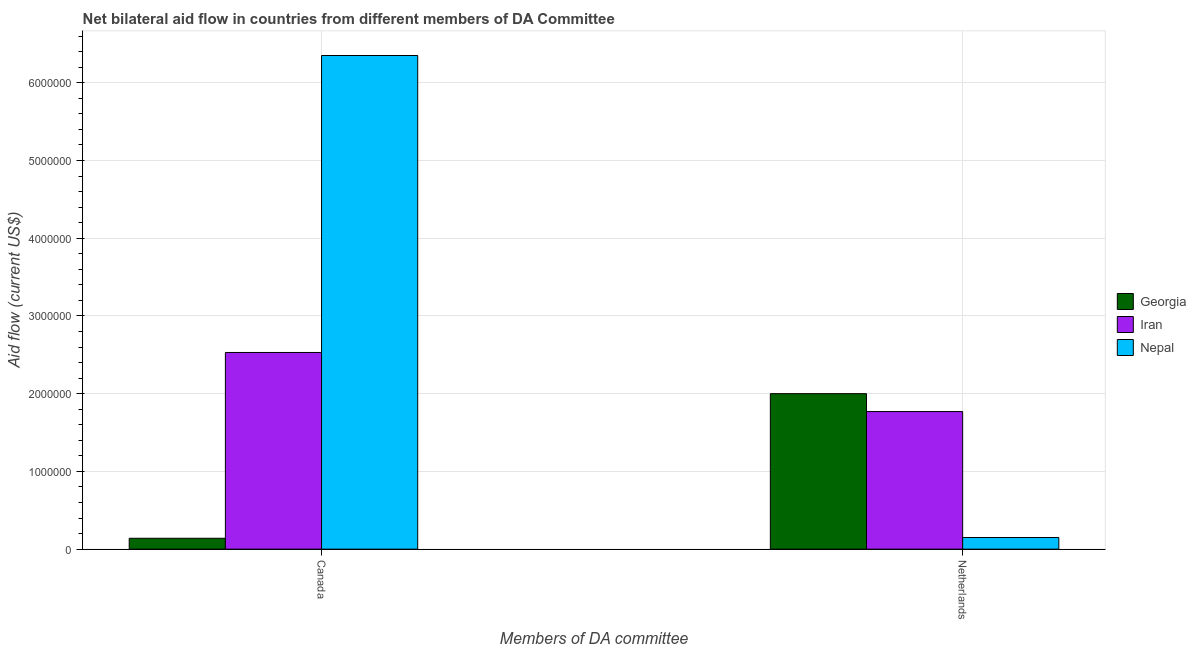How many groups of bars are there?
Your response must be concise. 2. Are the number of bars per tick equal to the number of legend labels?
Offer a very short reply. Yes. Are the number of bars on each tick of the X-axis equal?
Offer a terse response. Yes. How many bars are there on the 2nd tick from the left?
Offer a terse response. 3. What is the label of the 1st group of bars from the left?
Ensure brevity in your answer.  Canada. What is the amount of aid given by netherlands in Iran?
Provide a succinct answer. 1.77e+06. Across all countries, what is the maximum amount of aid given by netherlands?
Provide a succinct answer. 2.00e+06. Across all countries, what is the minimum amount of aid given by canada?
Keep it short and to the point. 1.40e+05. In which country was the amount of aid given by canada maximum?
Provide a short and direct response. Nepal. In which country was the amount of aid given by canada minimum?
Make the answer very short. Georgia. What is the total amount of aid given by netherlands in the graph?
Keep it short and to the point. 3.92e+06. What is the difference between the amount of aid given by canada in Nepal and that in Georgia?
Your answer should be very brief. 6.21e+06. What is the difference between the amount of aid given by netherlands in Iran and the amount of aid given by canada in Nepal?
Your answer should be very brief. -4.58e+06. What is the average amount of aid given by netherlands per country?
Provide a short and direct response. 1.31e+06. What is the difference between the amount of aid given by netherlands and amount of aid given by canada in Iran?
Give a very brief answer. -7.60e+05. In how many countries, is the amount of aid given by canada greater than 6400000 US$?
Your answer should be very brief. 0. What is the ratio of the amount of aid given by canada in Georgia to that in Iran?
Give a very brief answer. 0.06. What does the 3rd bar from the left in Canada represents?
Ensure brevity in your answer.  Nepal. What does the 3rd bar from the right in Netherlands represents?
Your answer should be very brief. Georgia. How many bars are there?
Provide a short and direct response. 6. Are all the bars in the graph horizontal?
Your answer should be compact. No. Are the values on the major ticks of Y-axis written in scientific E-notation?
Your answer should be very brief. No. How many legend labels are there?
Provide a succinct answer. 3. What is the title of the graph?
Keep it short and to the point. Net bilateral aid flow in countries from different members of DA Committee. Does "Thailand" appear as one of the legend labels in the graph?
Offer a very short reply. No. What is the label or title of the X-axis?
Provide a succinct answer. Members of DA committee. What is the label or title of the Y-axis?
Offer a terse response. Aid flow (current US$). What is the Aid flow (current US$) in Georgia in Canada?
Provide a short and direct response. 1.40e+05. What is the Aid flow (current US$) of Iran in Canada?
Your response must be concise. 2.53e+06. What is the Aid flow (current US$) of Nepal in Canada?
Your response must be concise. 6.35e+06. What is the Aid flow (current US$) of Iran in Netherlands?
Offer a terse response. 1.77e+06. What is the Aid flow (current US$) in Nepal in Netherlands?
Make the answer very short. 1.50e+05. Across all Members of DA committee, what is the maximum Aid flow (current US$) in Iran?
Ensure brevity in your answer.  2.53e+06. Across all Members of DA committee, what is the maximum Aid flow (current US$) in Nepal?
Give a very brief answer. 6.35e+06. Across all Members of DA committee, what is the minimum Aid flow (current US$) in Iran?
Provide a succinct answer. 1.77e+06. Across all Members of DA committee, what is the minimum Aid flow (current US$) in Nepal?
Your answer should be very brief. 1.50e+05. What is the total Aid flow (current US$) in Georgia in the graph?
Your response must be concise. 2.14e+06. What is the total Aid flow (current US$) in Iran in the graph?
Your answer should be compact. 4.30e+06. What is the total Aid flow (current US$) in Nepal in the graph?
Provide a succinct answer. 6.50e+06. What is the difference between the Aid flow (current US$) in Georgia in Canada and that in Netherlands?
Ensure brevity in your answer.  -1.86e+06. What is the difference between the Aid flow (current US$) of Iran in Canada and that in Netherlands?
Ensure brevity in your answer.  7.60e+05. What is the difference between the Aid flow (current US$) of Nepal in Canada and that in Netherlands?
Offer a terse response. 6.20e+06. What is the difference between the Aid flow (current US$) in Georgia in Canada and the Aid flow (current US$) in Iran in Netherlands?
Offer a terse response. -1.63e+06. What is the difference between the Aid flow (current US$) in Iran in Canada and the Aid flow (current US$) in Nepal in Netherlands?
Make the answer very short. 2.38e+06. What is the average Aid flow (current US$) in Georgia per Members of DA committee?
Ensure brevity in your answer.  1.07e+06. What is the average Aid flow (current US$) in Iran per Members of DA committee?
Your answer should be very brief. 2.15e+06. What is the average Aid flow (current US$) in Nepal per Members of DA committee?
Give a very brief answer. 3.25e+06. What is the difference between the Aid flow (current US$) of Georgia and Aid flow (current US$) of Iran in Canada?
Provide a succinct answer. -2.39e+06. What is the difference between the Aid flow (current US$) in Georgia and Aid flow (current US$) in Nepal in Canada?
Offer a very short reply. -6.21e+06. What is the difference between the Aid flow (current US$) in Iran and Aid flow (current US$) in Nepal in Canada?
Ensure brevity in your answer.  -3.82e+06. What is the difference between the Aid flow (current US$) of Georgia and Aid flow (current US$) of Iran in Netherlands?
Give a very brief answer. 2.30e+05. What is the difference between the Aid flow (current US$) in Georgia and Aid flow (current US$) in Nepal in Netherlands?
Keep it short and to the point. 1.85e+06. What is the difference between the Aid flow (current US$) of Iran and Aid flow (current US$) of Nepal in Netherlands?
Your answer should be compact. 1.62e+06. What is the ratio of the Aid flow (current US$) in Georgia in Canada to that in Netherlands?
Make the answer very short. 0.07. What is the ratio of the Aid flow (current US$) in Iran in Canada to that in Netherlands?
Provide a succinct answer. 1.43. What is the ratio of the Aid flow (current US$) in Nepal in Canada to that in Netherlands?
Your response must be concise. 42.33. What is the difference between the highest and the second highest Aid flow (current US$) in Georgia?
Make the answer very short. 1.86e+06. What is the difference between the highest and the second highest Aid flow (current US$) in Iran?
Make the answer very short. 7.60e+05. What is the difference between the highest and the second highest Aid flow (current US$) of Nepal?
Your answer should be very brief. 6.20e+06. What is the difference between the highest and the lowest Aid flow (current US$) in Georgia?
Your response must be concise. 1.86e+06. What is the difference between the highest and the lowest Aid flow (current US$) in Iran?
Your answer should be very brief. 7.60e+05. What is the difference between the highest and the lowest Aid flow (current US$) in Nepal?
Give a very brief answer. 6.20e+06. 